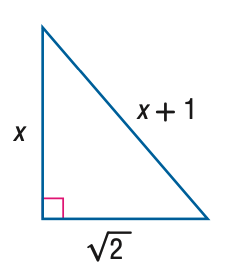Question: Find x.
Choices:
A. 0.5
B. 1
C. 2
D. 3
Answer with the letter. Answer: A 